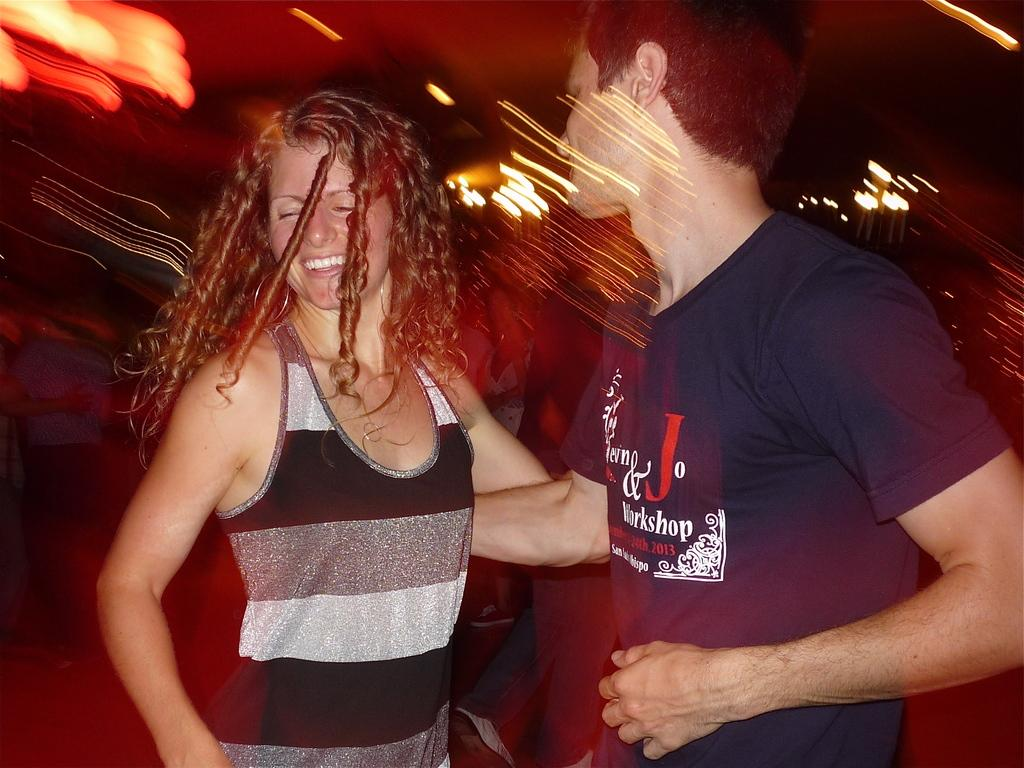Who is present in the image? There is a couple in the image. What is the couple doing in the image? The couple is smiling in the image. Are there any other people visible in the image? Yes, there are a few people behind the couple. How would you describe the background of the image? The background of the image is blurred. What book is the couple reading together in the image? There is no book present in the image; the couple is simply smiling. 